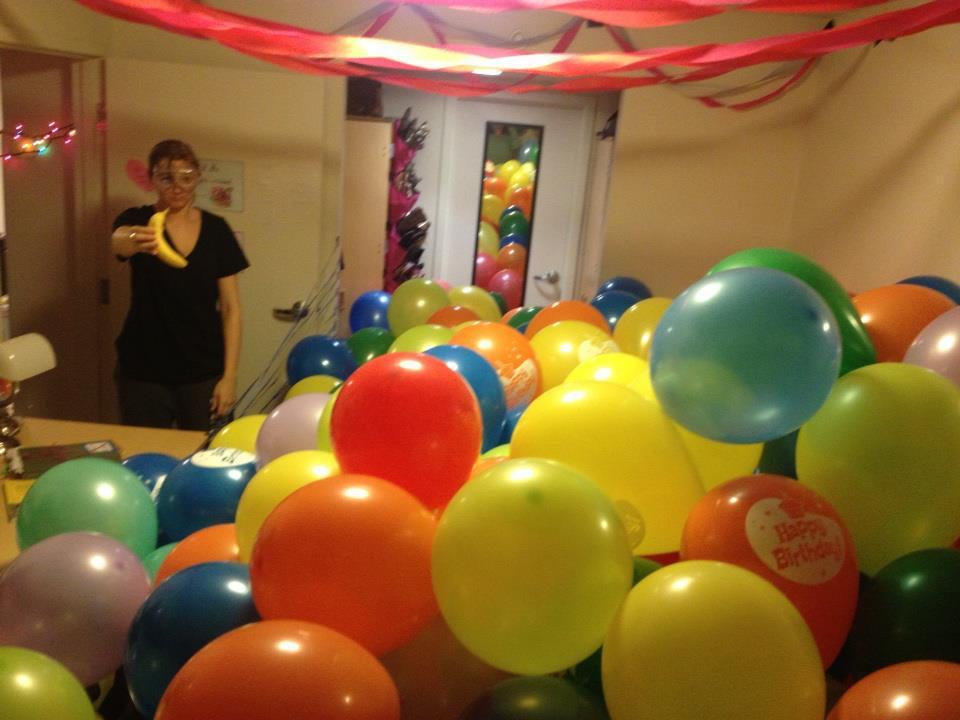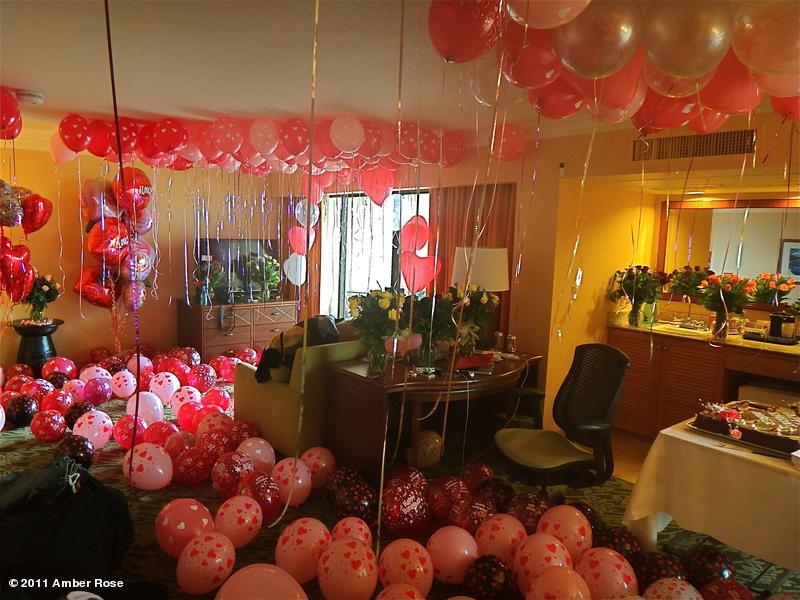The first image is the image on the left, the second image is the image on the right. For the images shown, is this caption "There is a heart shaped balloon in both images." true? Answer yes or no. No. The first image is the image on the left, the second image is the image on the right. Analyze the images presented: Is the assertion "There is a man outside walking with at least ten red balloons." valid? Answer yes or no. No. 